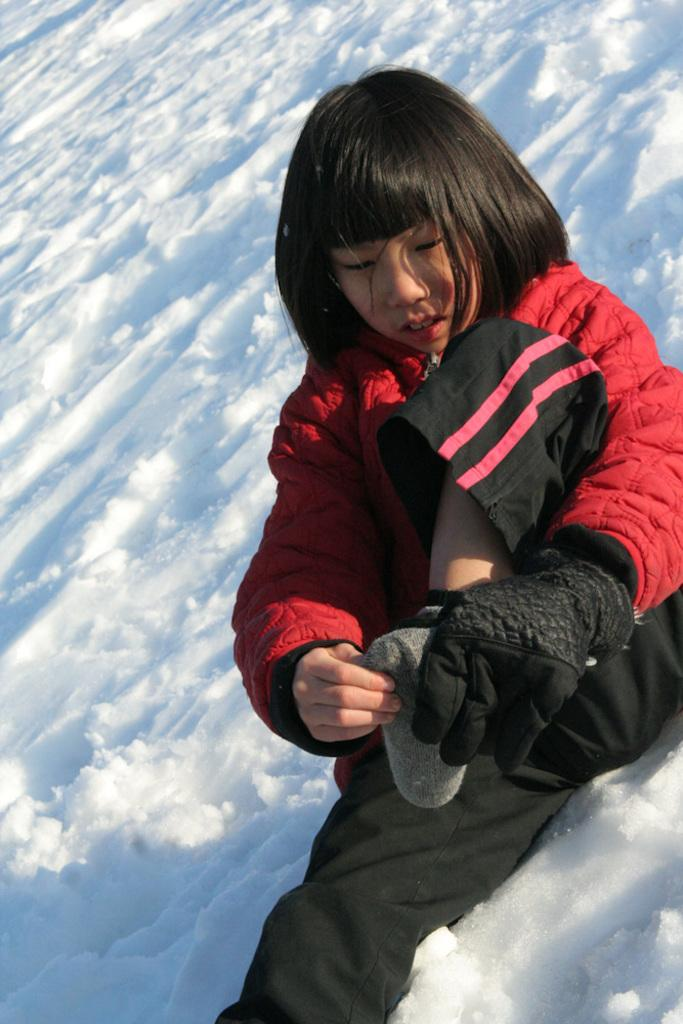Who is the main subject in the image? There is a girl in the image. What is the girl wearing? The girl is wearing a red jacket and black gloves. What is the setting of the image? The girl is sitting in the snow. Can you describe the environment in the image? There is snow at the bottom of the image. What type of paint is being used by the girl in the image? There is no paint or painting activity depicted in the image. 